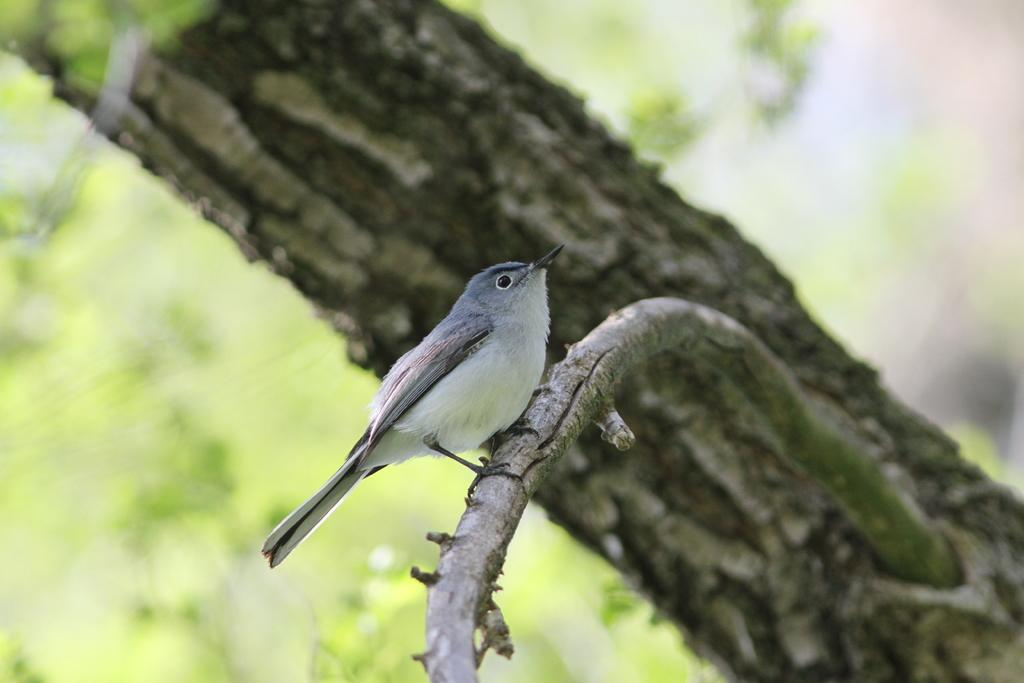What type of animal is present in the image? There is a bird in the image. Where is the bird located? The bird is on the branch of a tree. What part of the tree can be seen in the image? There is a tree trunk visible in the background of the image. How would you describe the clarity of the image? The image is blurry, but objects can still be seen. What type of minute can be seen in the image? There are no minutes present in the image; it features a bird on a tree branch. What type of produce is visible in the image? There is no produce visible in the image; it features a bird on a tree branch. 